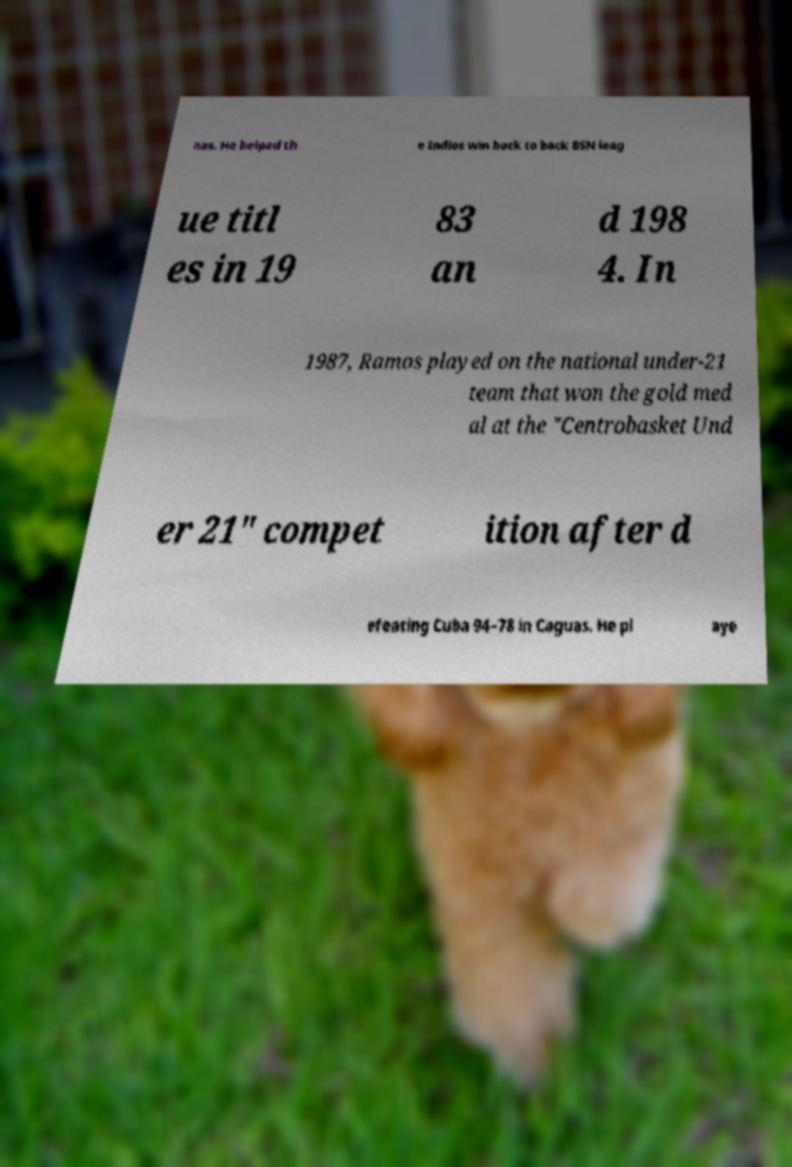Could you assist in decoding the text presented in this image and type it out clearly? nas. He helped th e Indios win back to back BSN leag ue titl es in 19 83 an d 198 4. In 1987, Ramos played on the national under-21 team that won the gold med al at the "Centrobasket Und er 21" compet ition after d efeating Cuba 94–78 in Caguas. He pl aye 